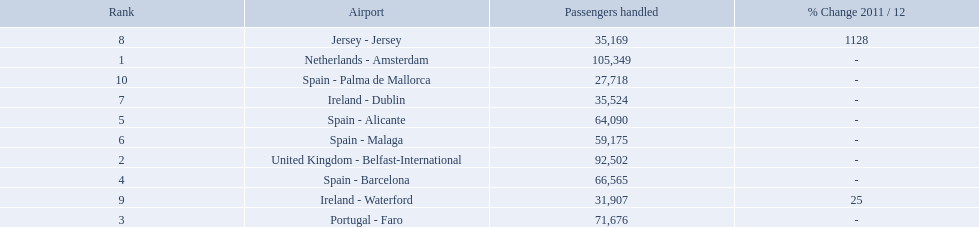What is the highest number of passengers handled? 105,349. What is the destination of the passengers leaving the area that handles 105,349 travellers? Netherlands - Amsterdam. Could you help me parse every detail presented in this table? {'header': ['Rank', 'Airport', 'Passengers handled', '% Change 2011 / 12'], 'rows': [['8', 'Jersey - Jersey', '35,169', '1128'], ['1', 'Netherlands - Amsterdam', '105,349', '-'], ['10', 'Spain - Palma de Mallorca', '27,718', '-'], ['7', 'Ireland - Dublin', '35,524', '-'], ['5', 'Spain - Alicante', '64,090', '-'], ['6', 'Spain - Malaga', '59,175', '-'], ['2', 'United Kingdom - Belfast-International', '92,502', '-'], ['4', 'Spain - Barcelona', '66,565', '-'], ['9', 'Ireland - Waterford', '31,907', '25'], ['3', 'Portugal - Faro', '71,676', '-']]} Name all the london southend airports that did not list a change in 2001/12. Netherlands - Amsterdam, United Kingdom - Belfast-International, Portugal - Faro, Spain - Barcelona, Spain - Alicante, Spain - Malaga, Ireland - Dublin, Spain - Palma de Mallorca. What unchanged percentage airports from 2011/12 handled less then 50,000 passengers? Ireland - Dublin, Spain - Palma de Mallorca. What unchanged percentage airport from 2011/12 handled less then 50,000 passengers is the closest to the equator? Spain - Palma de Mallorca. What are all of the destinations out of the london southend airport? Netherlands - Amsterdam, United Kingdom - Belfast-International, Portugal - Faro, Spain - Barcelona, Spain - Alicante, Spain - Malaga, Ireland - Dublin, Jersey - Jersey, Ireland - Waterford, Spain - Palma de Mallorca. How many passengers has each destination handled? 105,349, 92,502, 71,676, 66,565, 64,090, 59,175, 35,524, 35,169, 31,907, 27,718. And of those, which airport handled the fewest passengers? Spain - Palma de Mallorca. Which airports are in europe? Netherlands - Amsterdam, United Kingdom - Belfast-International, Portugal - Faro, Spain - Barcelona, Spain - Alicante, Spain - Malaga, Ireland - Dublin, Ireland - Waterford, Spain - Palma de Mallorca. Which one is from portugal? Portugal - Faro. 